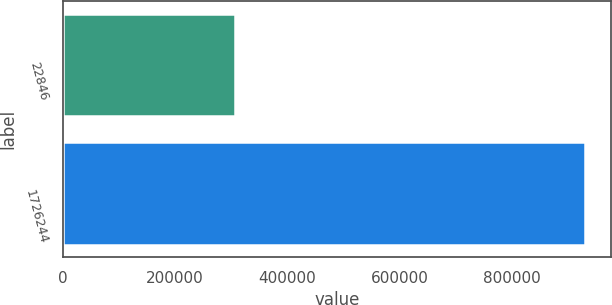Convert chart. <chart><loc_0><loc_0><loc_500><loc_500><bar_chart><fcel>22846<fcel>1726244<nl><fcel>306490<fcel>930493<nl></chart> 